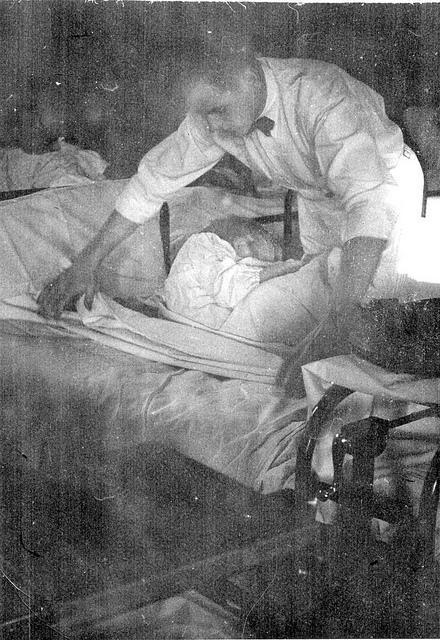How many people are in the picture?
Give a very brief answer. 2. 